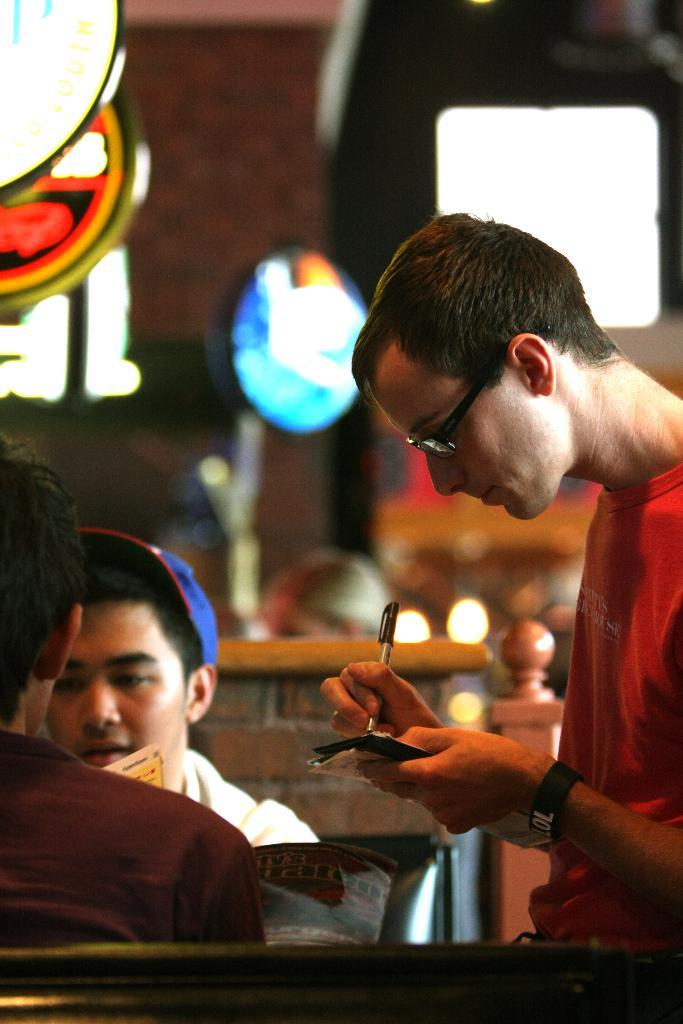How many people are in the image? There are people in the image, but the exact number is not specified. What is one person doing in the image? One person is holding a book with a pen. What other reading material is present in the image? There is a magazine in the image. What can be seen in the background of the image? There are lights, a wall, and some objects in the background of the image. Reasoning: Let's think step in order to produce the conversation. We start by acknowledging the presence of people in the image, but we avoid specifying the exact number since it is not mentioned in the facts. Then, we focus on the actions of one person, who is holding a book with a pen. Next, we mention another reading material present in the image, which is the magazine. Finally, we describe the background of the image, including lights, a wall, and some objects. Absurd Question/Answer: What type of cable is being used as bait in the image? There is no cable or bait present in the image. Is there a hammer visible in the image? No, there is no hammer visible in the image. 